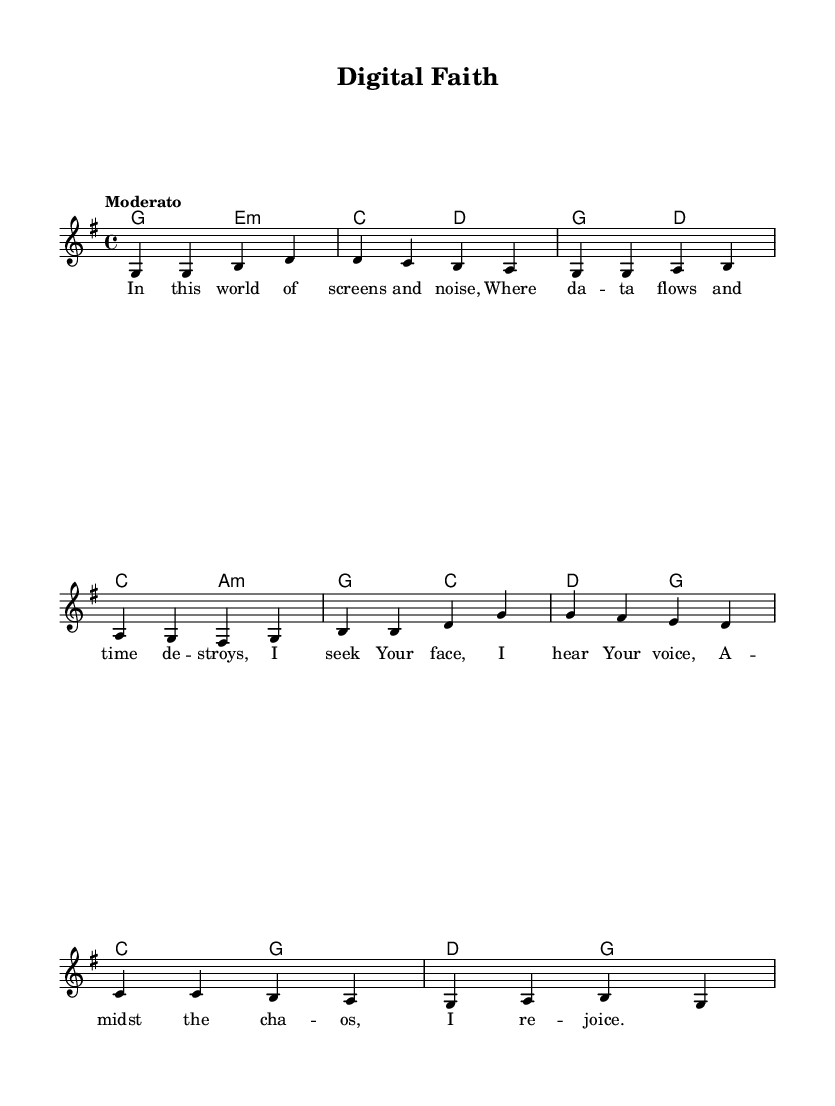What is the key signature of this music? The key signature is indicated at the beginning of the music, showing one sharp on the staff, which corresponds to G major.
Answer: G major What is the time signature of this music? The time signature is found at the beginning of the staff and is indicated as 4/4, meaning there are four beats in each measure and a quarter note gets one beat.
Answer: 4/4 What is the tempo marking for this piece? The tempo marking "Moderato" is located at the beginning of the score, suggesting a moderate pace for the performance.
Answer: Moderato How many measures are in the melody? To find the number of measures, we can count the groups of notes separated by vertical lines. There are a total of 8 measures in the melody section.
Answer: 8 What is the first line of the lyrics? The first line of the lyrics can be identified directly from the lyric mode section at the beginning, which states "In this world of screens and noise."
Answer: In this world of screens and noise How does the harmony relate to the melody in the first measure? In the first measure, the melody starts with the note G and the harmony is G major, which supports the melody note by providing the base that complements it harmonically. The G major chord contains the notes G, B, and D, matching the melody's starting note.
Answer: G major supports G What theme is expressed in the lyrics of this hymn? The lyrics express themes of seeking divine presence amidst chaos, referencing modern life's distractions and the search for spiritual peace.
Answer: Seeking divine presence 